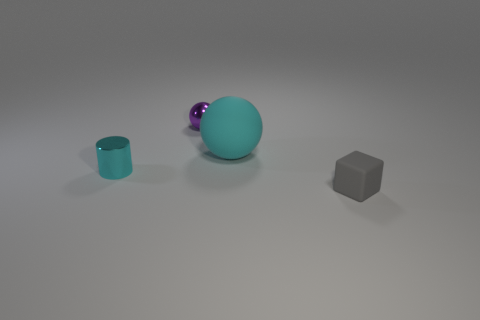Subtract all cyan balls. How many balls are left? 1 Add 1 tiny purple metal objects. How many objects exist? 5 Subtract all cubes. How many objects are left? 3 Add 4 gray rubber blocks. How many gray rubber blocks are left? 5 Add 1 cyan metal things. How many cyan metal things exist? 2 Subtract 0 cyan cubes. How many objects are left? 4 Subtract all tiny red cubes. Subtract all small metal spheres. How many objects are left? 3 